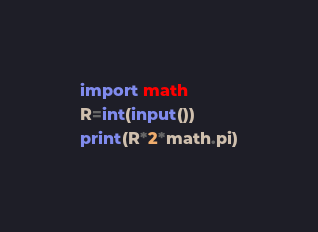Convert code to text. <code><loc_0><loc_0><loc_500><loc_500><_Python_>import math
R=int(input())
print(R*2*math.pi)</code> 